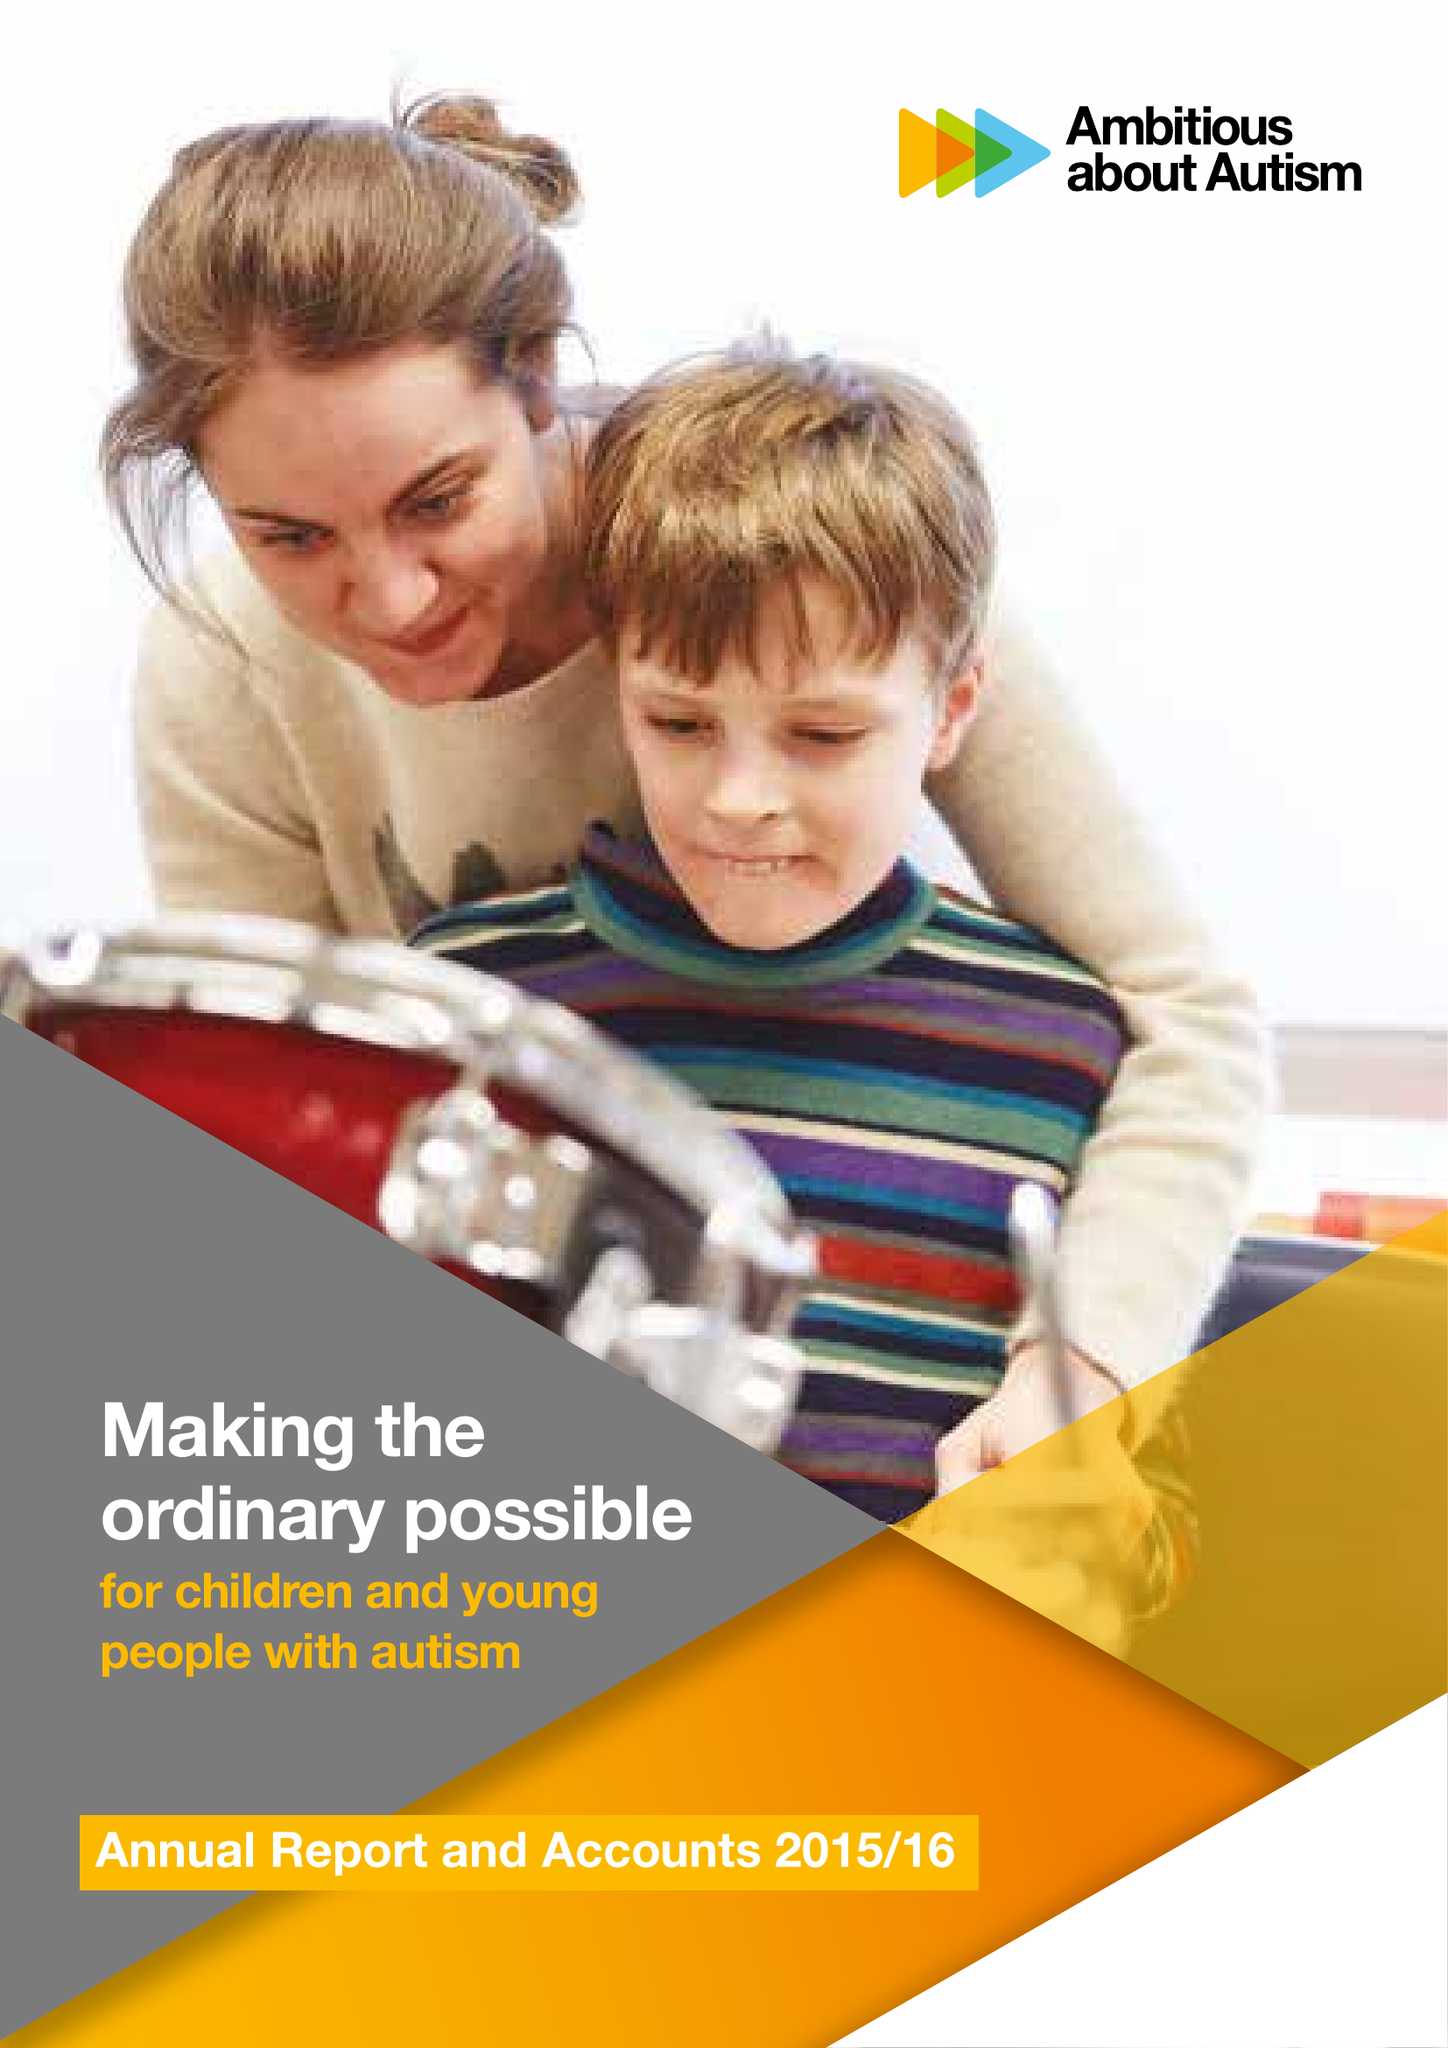What is the value for the charity_name?
Answer the question using a single word or phrase. Ambitious About Autism 